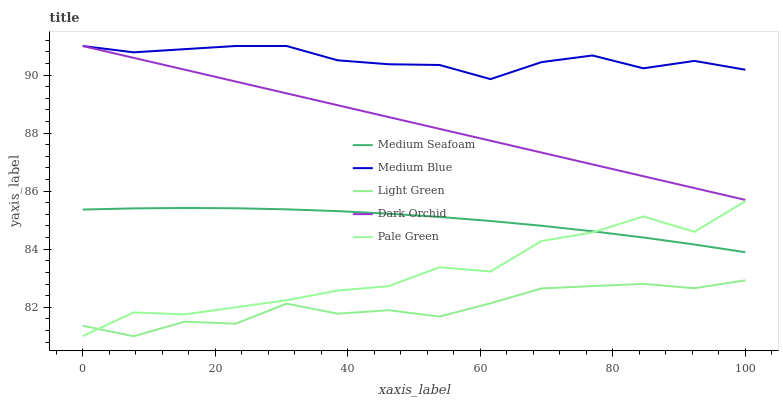Does Light Green have the minimum area under the curve?
Answer yes or no. Yes. Does Medium Blue have the maximum area under the curve?
Answer yes or no. Yes. Does Pale Green have the minimum area under the curve?
Answer yes or no. No. Does Pale Green have the maximum area under the curve?
Answer yes or no. No. Is Dark Orchid the smoothest?
Answer yes or no. Yes. Is Pale Green the roughest?
Answer yes or no. Yes. Is Medium Blue the smoothest?
Answer yes or no. No. Is Medium Blue the roughest?
Answer yes or no. No. Does Light Green have the lowest value?
Answer yes or no. Yes. Does Pale Green have the lowest value?
Answer yes or no. No. Does Medium Blue have the highest value?
Answer yes or no. Yes. Does Pale Green have the highest value?
Answer yes or no. No. Is Pale Green less than Dark Orchid?
Answer yes or no. Yes. Is Dark Orchid greater than Pale Green?
Answer yes or no. Yes. Does Dark Orchid intersect Medium Blue?
Answer yes or no. Yes. Is Dark Orchid less than Medium Blue?
Answer yes or no. No. Is Dark Orchid greater than Medium Blue?
Answer yes or no. No. Does Pale Green intersect Dark Orchid?
Answer yes or no. No. 